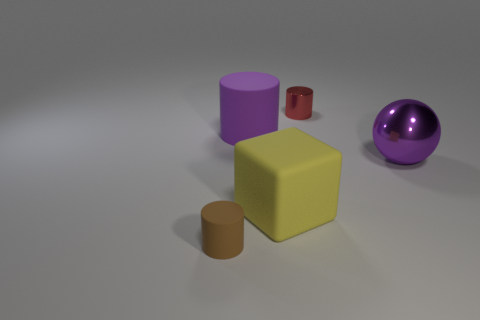The big matte object that is the same color as the ball is what shape?
Your response must be concise. Cylinder. Are there the same number of large purple spheres left of the tiny metallic thing and small red cylinders?
Provide a short and direct response. No. What shape is the purple shiny thing that is the same size as the yellow rubber object?
Offer a very short reply. Sphere. What material is the tiny brown thing?
Your answer should be very brief. Rubber. There is a object that is both behind the purple ball and in front of the small red object; what color is it?
Offer a very short reply. Purple. Is the number of tiny red metallic cylinders that are in front of the tiny metallic cylinder the same as the number of yellow rubber blocks in front of the purple rubber object?
Ensure brevity in your answer.  No. What color is the tiny cylinder that is the same material as the large purple sphere?
Your response must be concise. Red. There is a ball; is its color the same as the tiny object that is right of the tiny brown cylinder?
Keep it short and to the point. No. Are there any small red things that are to the right of the tiny cylinder that is behind the object that is left of the big purple rubber cylinder?
Your response must be concise. No. The big yellow thing that is the same material as the brown object is what shape?
Provide a succinct answer. Cube. 